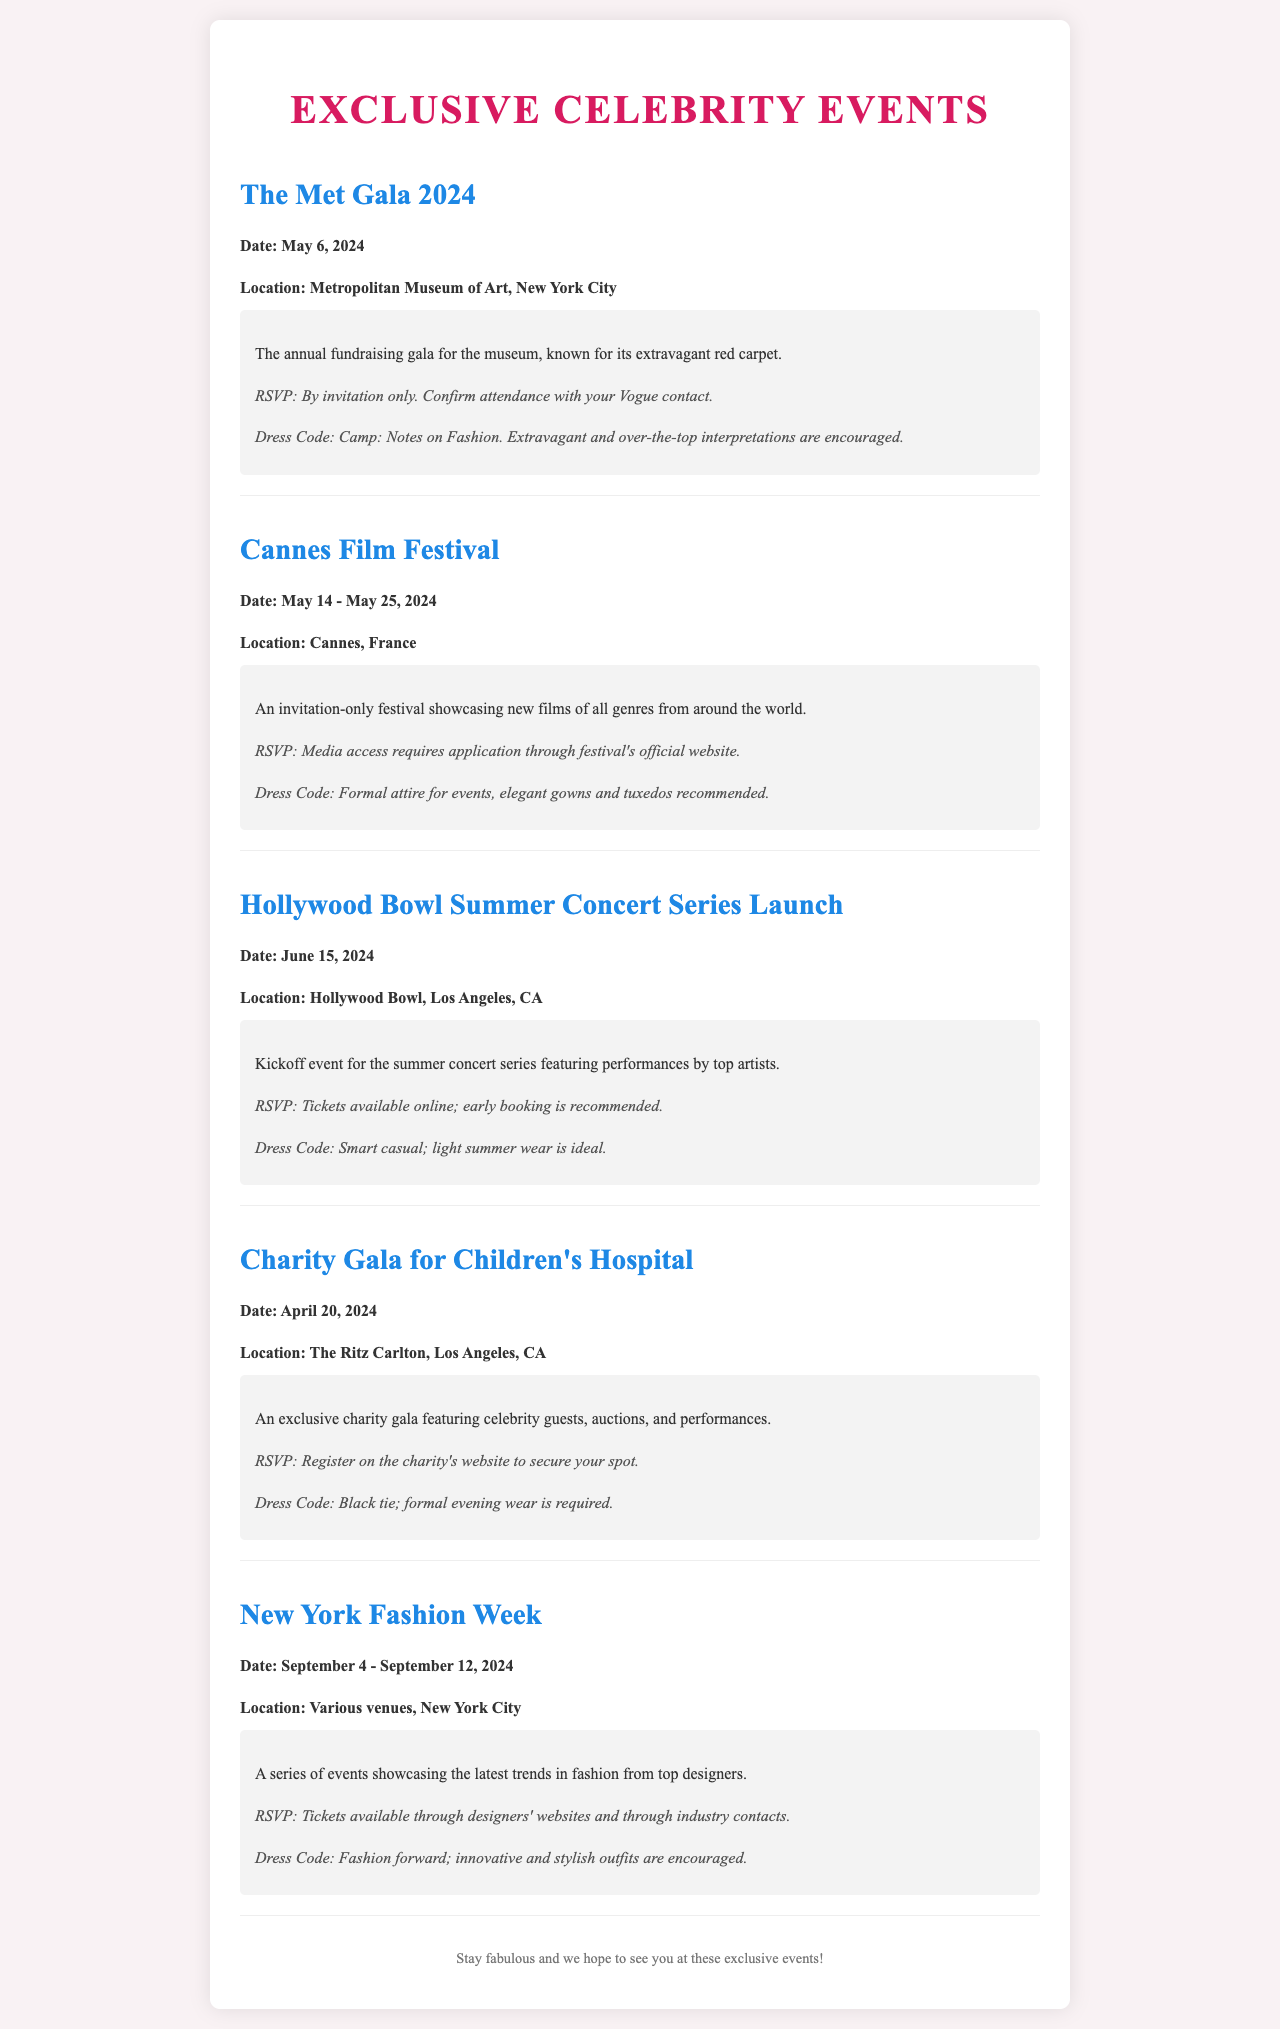What is the date of the Met Gala 2024? The date of the Met Gala 2024 is mentioned in the document as May 6, 2024.
Answer: May 6, 2024 Where is the Cannes Film Festival held? The location of the Cannes Film Festival is specified as Cannes, France.
Answer: Cannes, France What is the dress code for the Charity Gala for Children's Hospital? The dress code for the Charity Gala is stated as black tie; formal evening wear is required.
Answer: Black tie When does New York Fashion Week take place? The document states that New York Fashion Week runs from September 4 to September 12, 2024.
Answer: September 4 - September 12, 2024 What is required for RSVP to the Hollywood Bowl Summer Concert Series Launch? The RSVP details indicate that tickets are available online and early booking is recommended.
Answer: Tickets available online What type of attire is suggested for the Cannes Film Festival? The dress code for the Cannes Film Festival is described as formal attire, with elegant gowns and tuxedos recommended.
Answer: Formal attire How does one RSVP for the Met Gala? The RSVP process for the Met Gala is described as by invitation only, with confirmation through a Vogue contact.
Answer: By invitation only Which event features celebrity guests and auctions? The event that features celebrity guests, auctions, and performances is the Charity Gala for Children's Hospital.
Answer: Charity Gala for Children's Hospital 